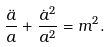Convert formula to latex. <formula><loc_0><loc_0><loc_500><loc_500>\frac { \ddot { a } } { a } + \frac { \dot { a } ^ { 2 } } { a ^ { 2 } } = m ^ { 2 } .</formula> 